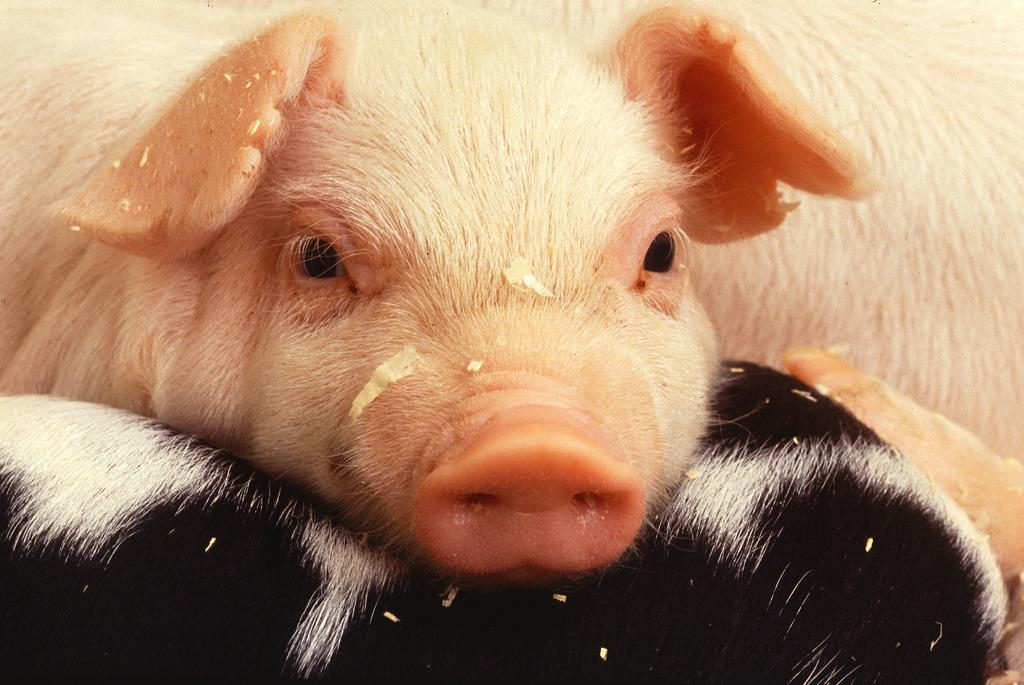What type of animal is present in the image? There is a pig in the image. Can you describe the color pattern of the other animal in the image? The other animal has white and black color hair. What type of roof can be seen on the pig's house in the image? There is no house or roof present in the image; it only features the pig and the other animal. Can you describe the self-awareness of the pig in the image? There is no indication of self-awareness or any other cognitive abilities of the pig in the image. 